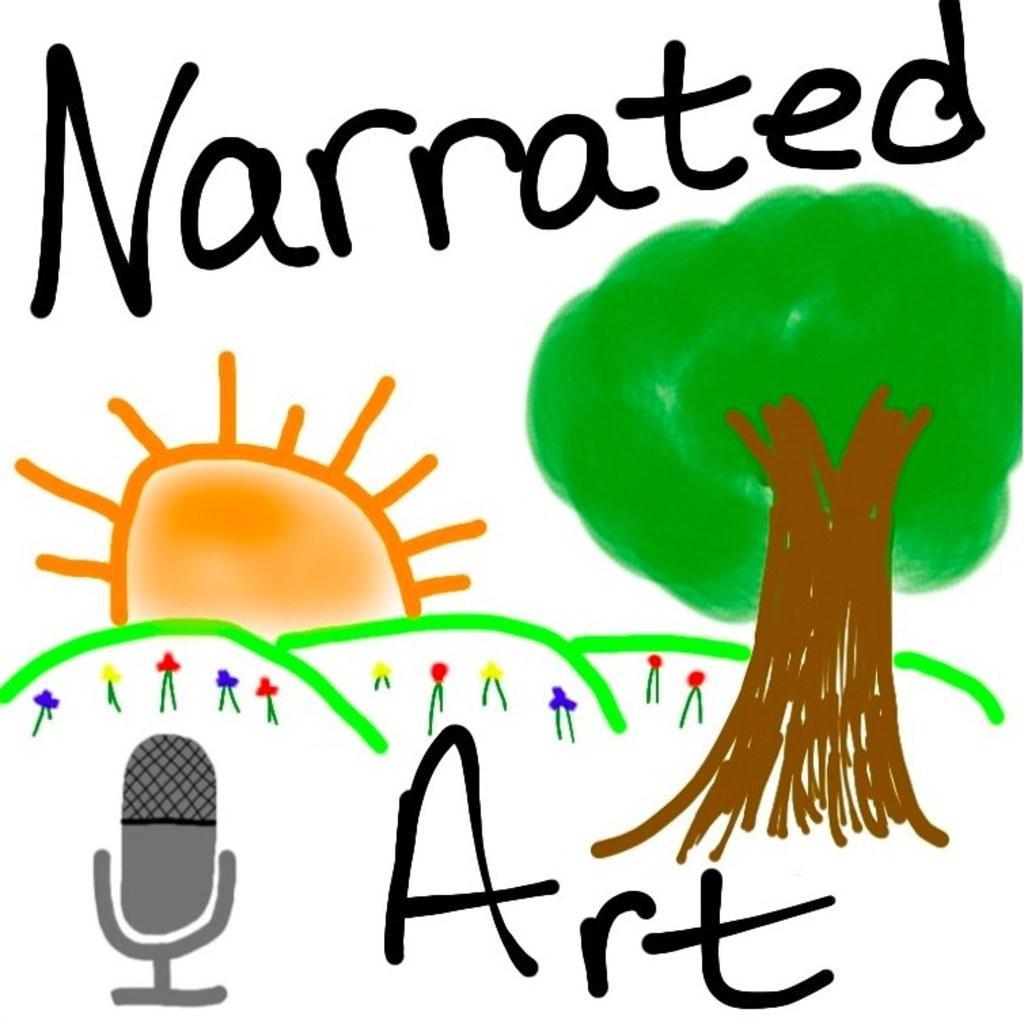Please provide a concise description of this image. In this image we can see an art in which there are some plants, tree, sun and some text. 